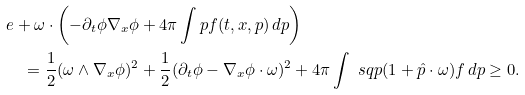<formula> <loc_0><loc_0><loc_500><loc_500>& e + \omega \cdot \left ( - \partial _ { t } \phi \nabla _ { x } \phi + 4 \pi \int p f ( t , x , p ) \, d p \right ) \\ & \quad = \frac { 1 } { 2 } ( \omega \wedge \nabla _ { x } \phi ) ^ { 2 } + \frac { 1 } { 2 } ( \partial _ { t } \phi - \nabla _ { x } \phi \cdot \omega ) ^ { 2 } + 4 \pi \int \ s q p ( 1 + \hat { p } \cdot \omega ) f \, d p \geq 0 .</formula> 